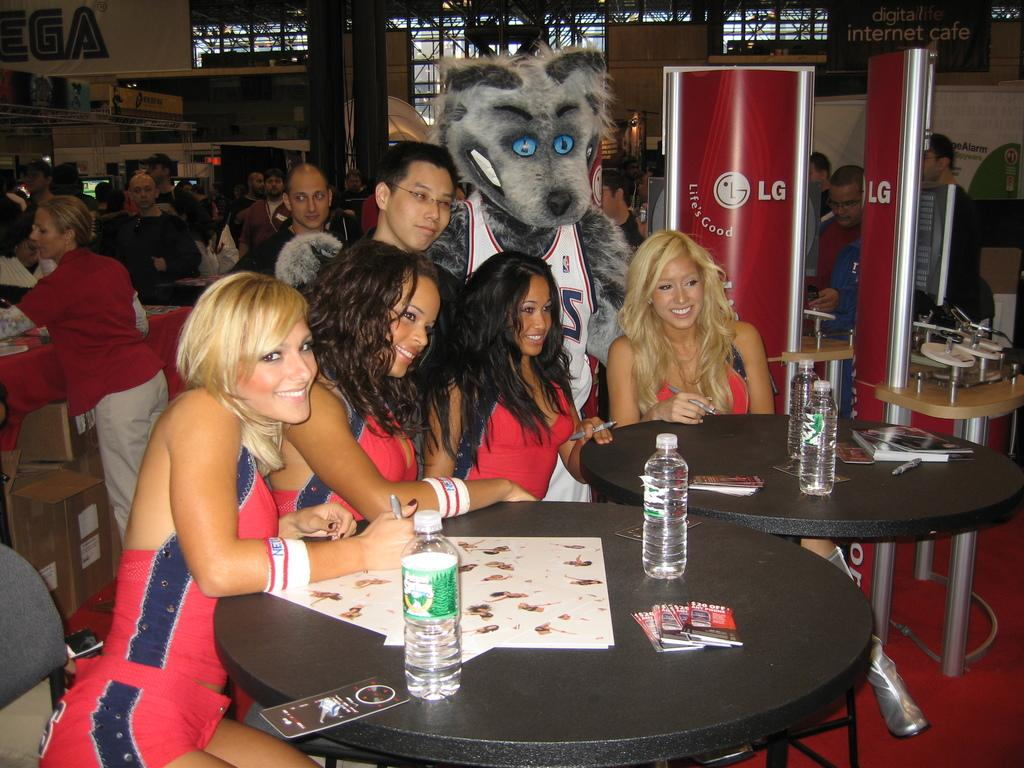How many ladies are in the image? There are four ladies in the image. What are the ladies doing in the image? The ladies are sitting around tables. What can be seen on the tables with the ladies? There are water bottles on the tables. Are there any other people present in the image besides the ladies? Yes, there are other people present in the image. What color is the cabbage being served to the ladies in the image? There is no cabbage present in the image, and therefore no such dish can be observed. 